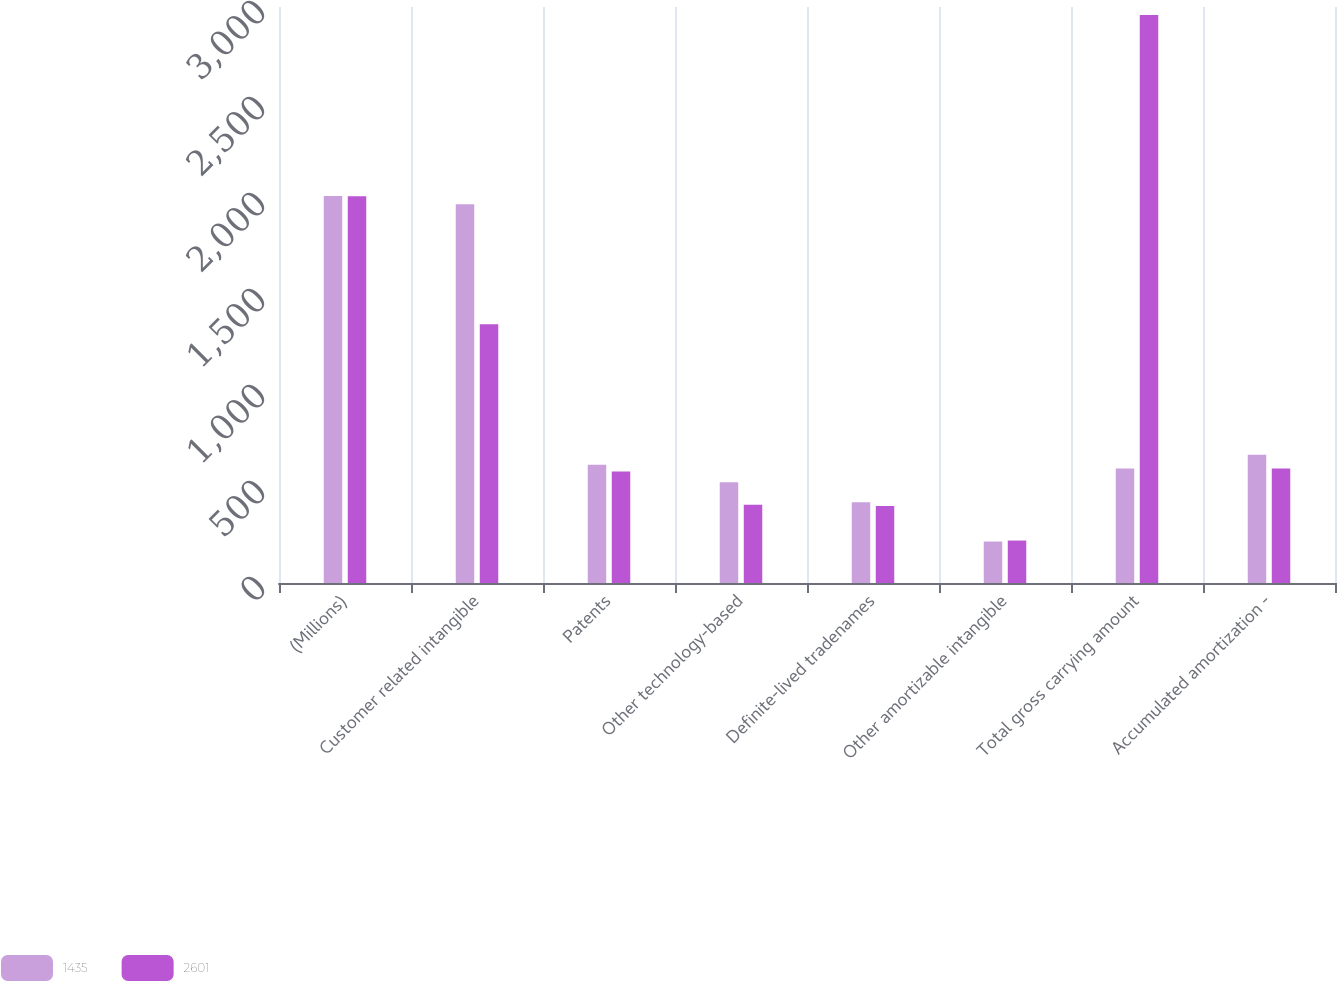Convert chart. <chart><loc_0><loc_0><loc_500><loc_500><stacked_bar_chart><ecel><fcel>(Millions)<fcel>Customer related intangible<fcel>Patents<fcel>Other technology-based<fcel>Definite-lived tradenames<fcel>Other amortizable intangible<fcel>Total gross carrying amount<fcel>Accumulated amortization -<nl><fcel>1435<fcel>2015<fcel>1973<fcel>616<fcel>525<fcel>421<fcel>216<fcel>597<fcel>668<nl><fcel>2601<fcel>2014<fcel>1348<fcel>581<fcel>407<fcel>401<fcel>221<fcel>2958<fcel>597<nl></chart> 